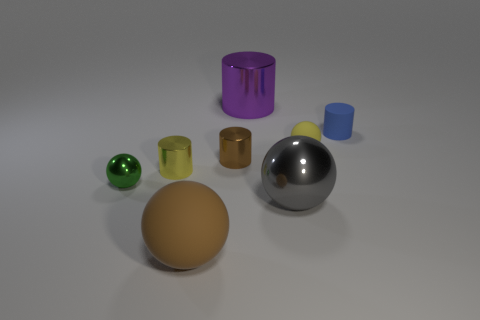There is a thing that is behind the tiny cylinder that is to the right of the brown cylinder; what is its material?
Your response must be concise. Metal. Do the large cylinder and the yellow thing on the right side of the yellow shiny cylinder have the same material?
Provide a succinct answer. No. There is a small cylinder that is both behind the yellow metal object and left of the small blue thing; what material is it?
Keep it short and to the point. Metal. There is a object that is to the right of the tiny yellow object that is behind the small brown cylinder; what is its color?
Provide a short and direct response. Blue. What is the material of the small sphere that is in front of the yellow cylinder?
Provide a short and direct response. Metal. Is the number of small rubber cylinders less than the number of blue metal blocks?
Provide a succinct answer. No. There is a large gray thing; is its shape the same as the matte object that is on the left side of the purple metallic thing?
Give a very brief answer. Yes. What is the shape of the shiny object that is in front of the yellow metal thing and to the right of the tiny green ball?
Keep it short and to the point. Sphere. Are there an equal number of spheres that are behind the yellow matte ball and yellow matte objects that are in front of the big gray object?
Offer a terse response. Yes. There is a gray metal object in front of the yellow cylinder; is it the same shape as the yellow rubber object?
Ensure brevity in your answer.  Yes. 